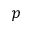<formula> <loc_0><loc_0><loc_500><loc_500>p</formula> 